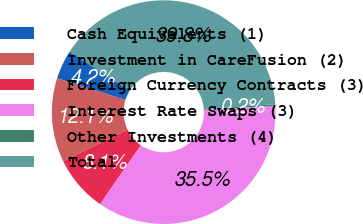Convert chart. <chart><loc_0><loc_0><loc_500><loc_500><pie_chart><fcel>Cash Equivalents (1)<fcel>Investment in CareFusion (2)<fcel>Foreign Currency Contracts (3)<fcel>Interest Rate Swaps (3)<fcel>Other Investments (4)<fcel>Total<nl><fcel>4.19%<fcel>12.12%<fcel>8.15%<fcel>35.53%<fcel>0.23%<fcel>39.78%<nl></chart> 